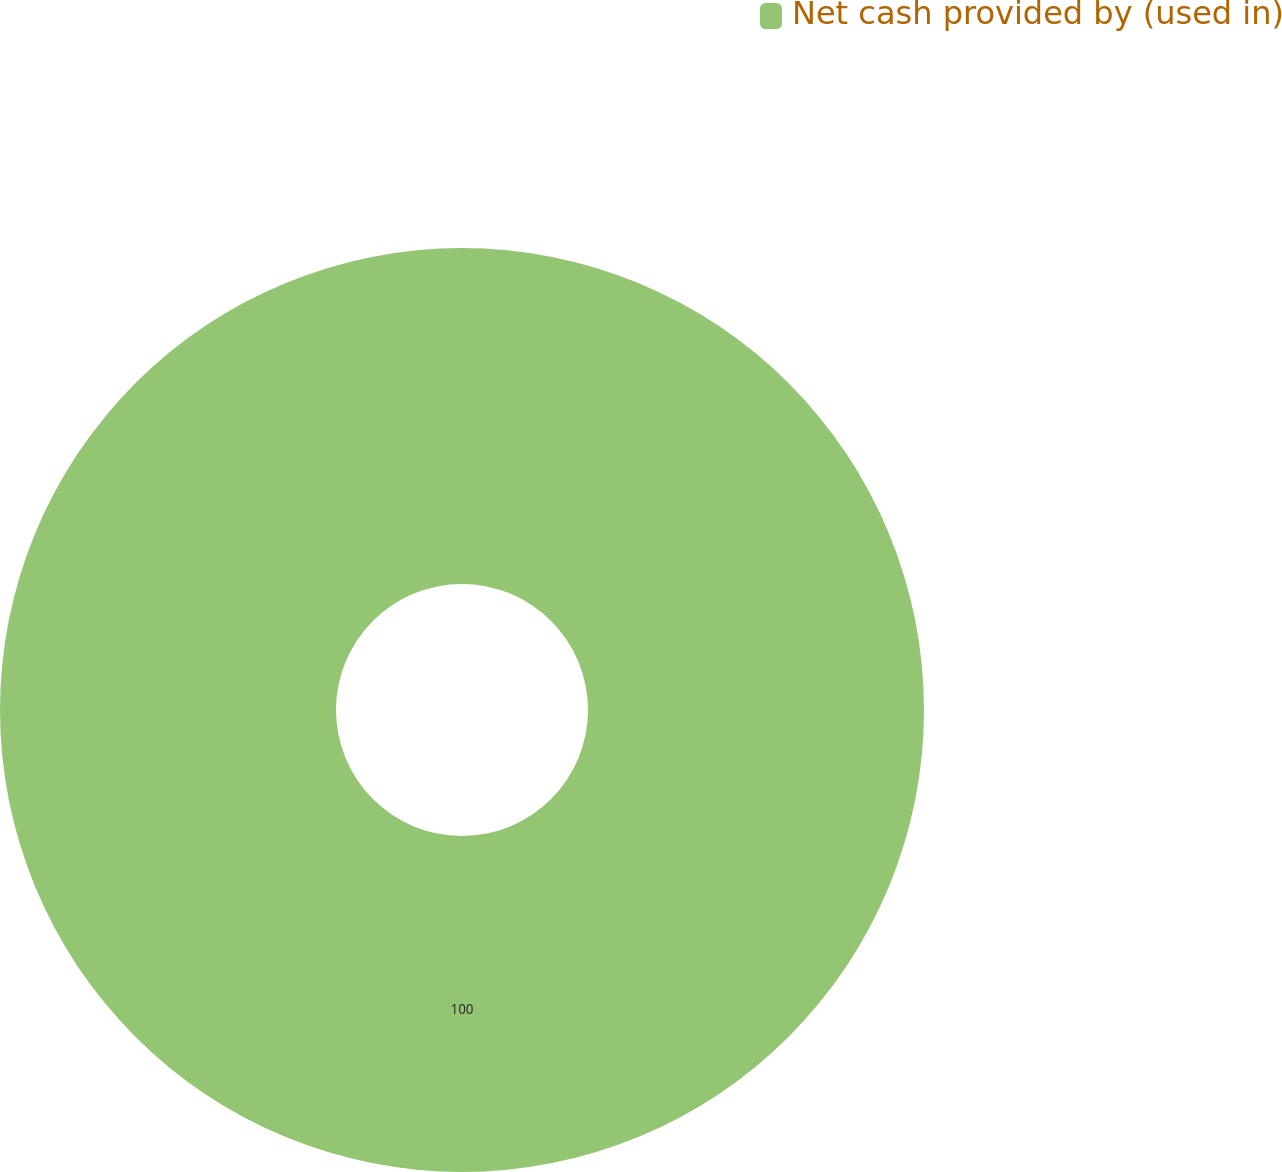<chart> <loc_0><loc_0><loc_500><loc_500><pie_chart><fcel>Net cash provided by (used in)<nl><fcel>100.0%<nl></chart> 